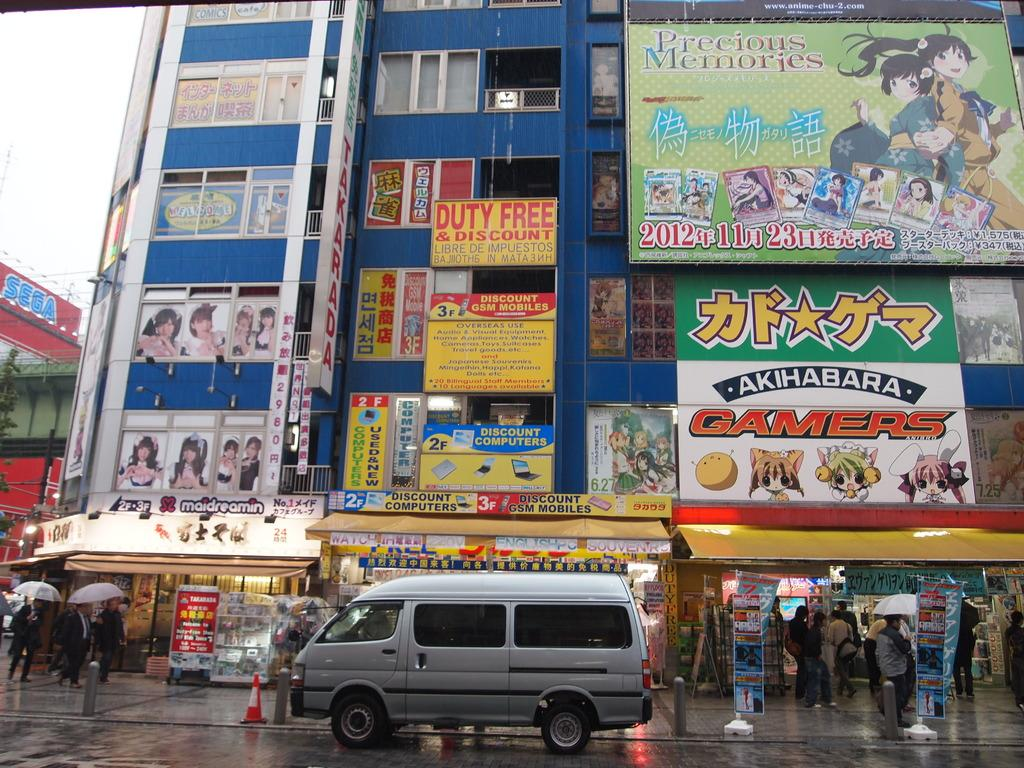What type of structures can be seen in the image? There are buildings in the image. What additional objects are present in the image? There are banners, a current pole, a van, a traffic cone, and umbrellas in the image. Can you describe the people in the image? There are people in the image, but their specific actions or appearances are not mentioned in the facts. What part of the natural environment is visible in the image? The sky is visible in the image. What type of net can be seen hanging from the buildings in the image? There is no mention of a net in the image; only buildings, banners, a current pole, a van, a traffic cone, and umbrellas are mentioned. How are the people washing the buildings in the image? There is no mention of people washing the buildings in the image; only the presence of people is noted. 